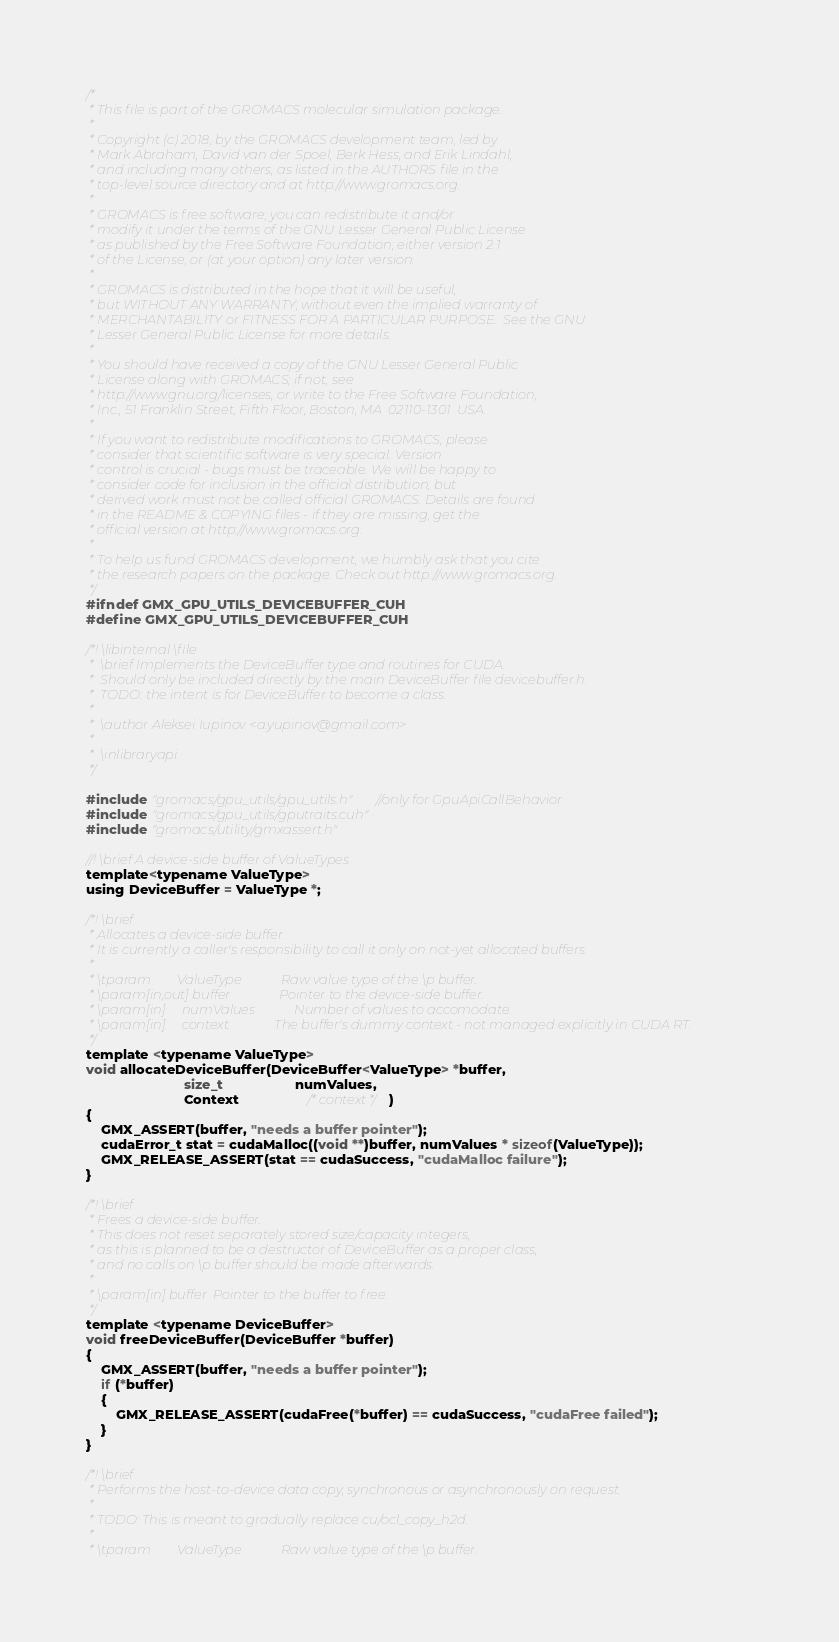Convert code to text. <code><loc_0><loc_0><loc_500><loc_500><_Cuda_>/*
 * This file is part of the GROMACS molecular simulation package.
 *
 * Copyright (c) 2018, by the GROMACS development team, led by
 * Mark Abraham, David van der Spoel, Berk Hess, and Erik Lindahl,
 * and including many others, as listed in the AUTHORS file in the
 * top-level source directory and at http://www.gromacs.org.
 *
 * GROMACS is free software; you can redistribute it and/or
 * modify it under the terms of the GNU Lesser General Public License
 * as published by the Free Software Foundation; either version 2.1
 * of the License, or (at your option) any later version.
 *
 * GROMACS is distributed in the hope that it will be useful,
 * but WITHOUT ANY WARRANTY; without even the implied warranty of
 * MERCHANTABILITY or FITNESS FOR A PARTICULAR PURPOSE.  See the GNU
 * Lesser General Public License for more details.
 *
 * You should have received a copy of the GNU Lesser General Public
 * License along with GROMACS; if not, see
 * http://www.gnu.org/licenses, or write to the Free Software Foundation,
 * Inc., 51 Franklin Street, Fifth Floor, Boston, MA  02110-1301  USA.
 *
 * If you want to redistribute modifications to GROMACS, please
 * consider that scientific software is very special. Version
 * control is crucial - bugs must be traceable. We will be happy to
 * consider code for inclusion in the official distribution, but
 * derived work must not be called official GROMACS. Details are found
 * in the README & COPYING files - if they are missing, get the
 * official version at http://www.gromacs.org.
 *
 * To help us fund GROMACS development, we humbly ask that you cite
 * the research papers on the package. Check out http://www.gromacs.org.
 */
#ifndef GMX_GPU_UTILS_DEVICEBUFFER_CUH
#define GMX_GPU_UTILS_DEVICEBUFFER_CUH

/*! \libinternal \file
 *  \brief Implements the DeviceBuffer type and routines for CUDA.
 *  Should only be included directly by the main DeviceBuffer file devicebuffer.h.
 *  TODO: the intent is for DeviceBuffer to become a class.
 *
 *  \author Aleksei Iupinov <a.yupinov@gmail.com>
 *
 *  \inlibraryapi
 */

#include "gromacs/gpu_utils/gpu_utils.h" //only for GpuApiCallBehavior
#include "gromacs/gpu_utils/gputraits.cuh"
#include "gromacs/utility/gmxassert.h"

//! \brief A device-side buffer of ValueTypes
template<typename ValueType>
using DeviceBuffer = ValueType *;

/*! \brief
 * Allocates a device-side buffer.
 * It is currently a caller's responsibility to call it only on not-yet allocated buffers.
 *
 * \tparam        ValueType            Raw value type of the \p buffer.
 * \param[in,out] buffer               Pointer to the device-side buffer.
 * \param[in]     numValues            Number of values to accomodate.
 * \param[in]     context              The buffer's dummy context - not managed explicitly in CUDA RT.
 */
template <typename ValueType>
void allocateDeviceBuffer(DeviceBuffer<ValueType> *buffer,
                          size_t                   numValues,
                          Context                  /* context */)
{
    GMX_ASSERT(buffer, "needs a buffer pointer");
    cudaError_t stat = cudaMalloc((void **)buffer, numValues * sizeof(ValueType));
    GMX_RELEASE_ASSERT(stat == cudaSuccess, "cudaMalloc failure");
}

/*! \brief
 * Frees a device-side buffer.
 * This does not reset separately stored size/capacity integers,
 * as this is planned to be a destructor of DeviceBuffer as a proper class,
 * and no calls on \p buffer should be made afterwards.
 *
 * \param[in] buffer  Pointer to the buffer to free.
 */
template <typename DeviceBuffer>
void freeDeviceBuffer(DeviceBuffer *buffer)
{
    GMX_ASSERT(buffer, "needs a buffer pointer");
    if (*buffer)
    {
        GMX_RELEASE_ASSERT(cudaFree(*buffer) == cudaSuccess, "cudaFree failed");
    }
}

/*! \brief
 * Performs the host-to-device data copy, synchronous or asynchronously on request.
 *
 * TODO: This is meant to gradually replace cu/ocl_copy_h2d.
 *
 * \tparam        ValueType            Raw value type of the \p buffer.</code> 